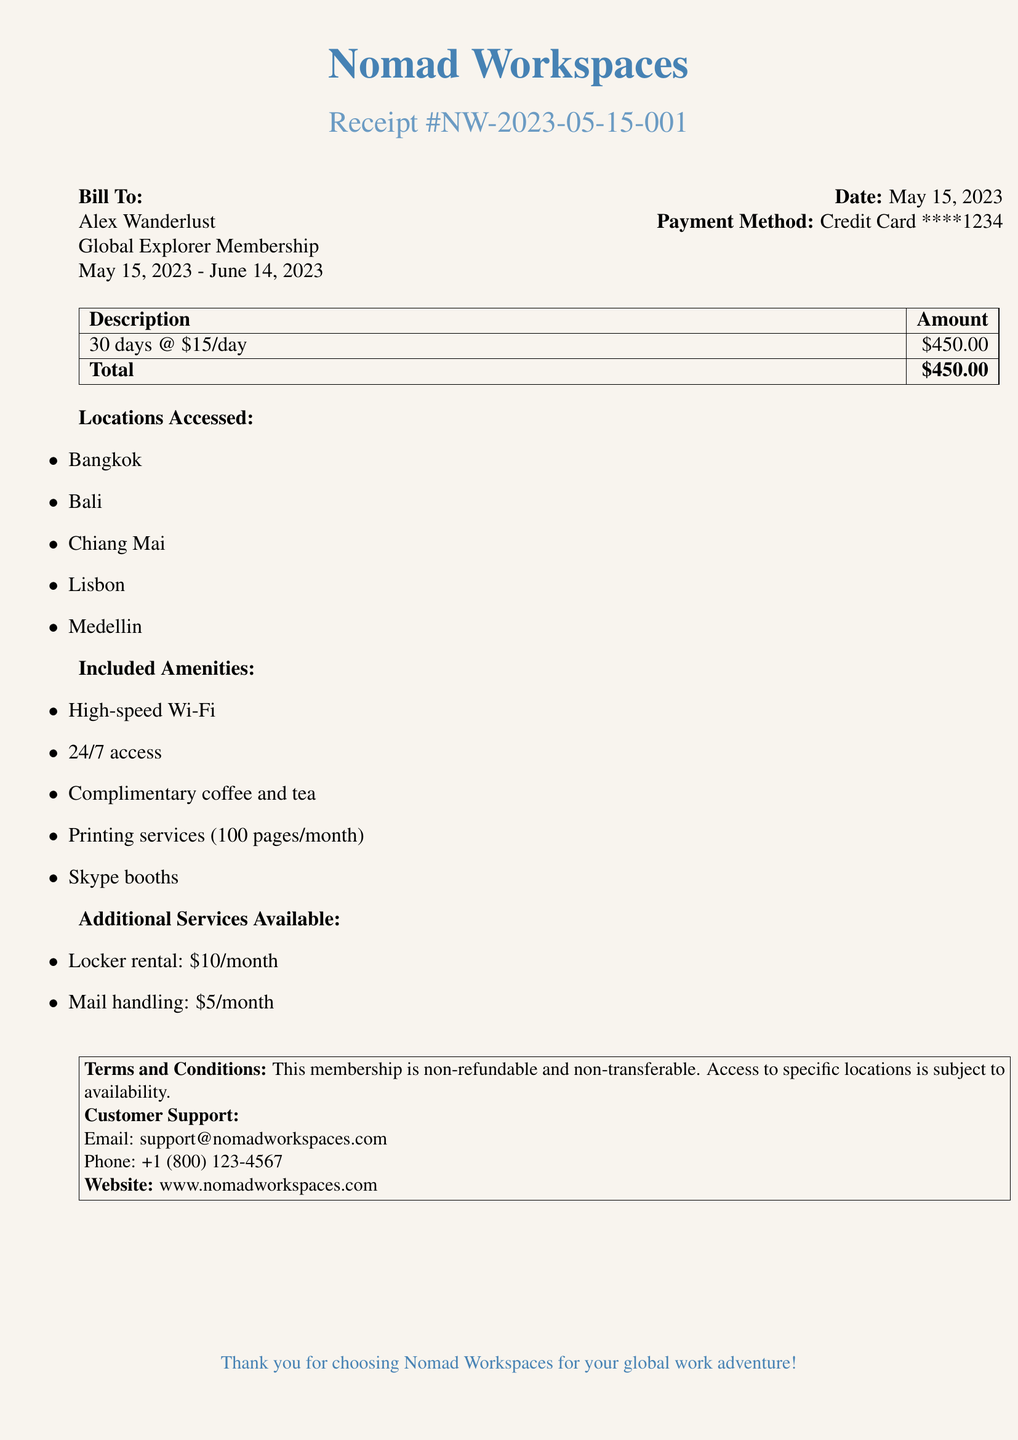What is the total amount billed? The total amount billed is listed at the bottom of the itemized section, indicating the sum of services provided.
Answer: $450.00 Who is the bill addressed to? The bill clearly states the recipient's name under "Bill To," which identifies the customer associated with the membership.
Answer: Alex Wanderlust What is the membership period? The membership period is indicated under the customer's information, detailing the duration between specific dates.
Answer: May 15, 2023 - June 14, 2023 How many locations were accessed? The locations accessed are listed in a bullet point format, allowing for easy counting of entries.
Answer: 5 What amenities are included? The amenities included are detailed in a section, providing a comprehensive list of services offered within the membership.
Answer: High-speed Wi-Fi, 24/7 access, complimentary coffee and tea, printing services (100 pages/month), Skype booths What additional service costs $10 per month? One of the additional services includes details about a rental option specified with its monthly fee.
Answer: Locker rental Is this membership refundable? The terms and conditions specify the nature of the membership regarding refunds, giving clarity on financial policies.
Answer: Non-refundable What is the payment method used? The payment method is stated in the header section of the document, reflecting how the billing was processed.
Answer: Credit Card ****1234 